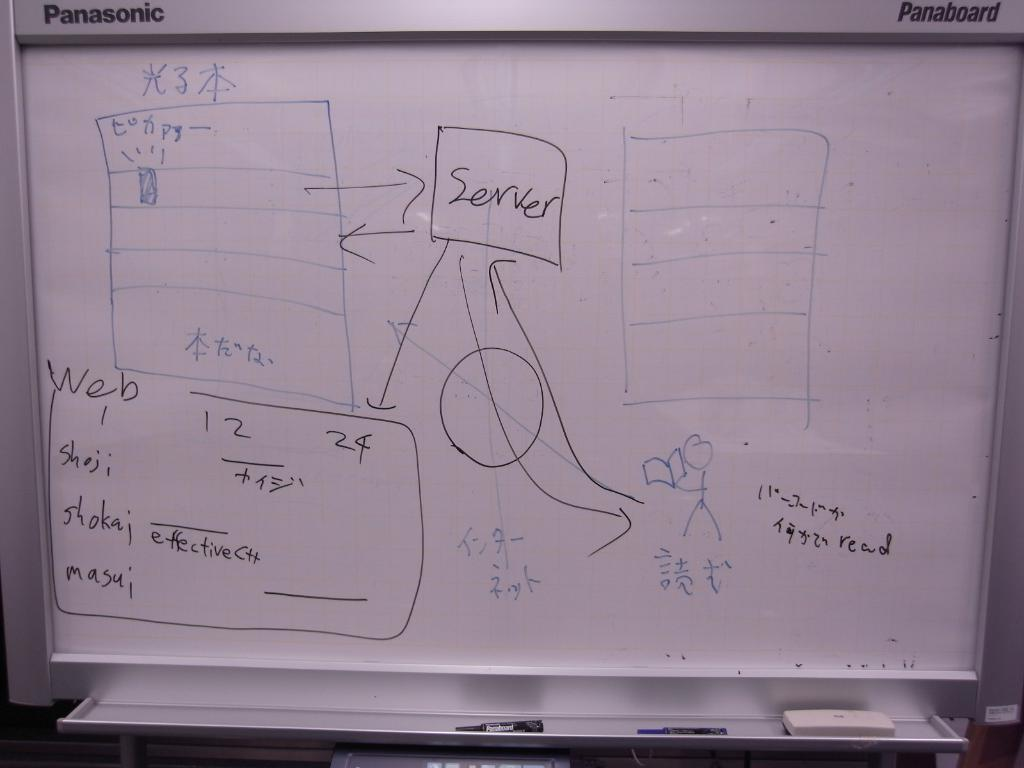<image>
Give a short and clear explanation of the subsequent image. A dry erase board has the word "server" in a box. 